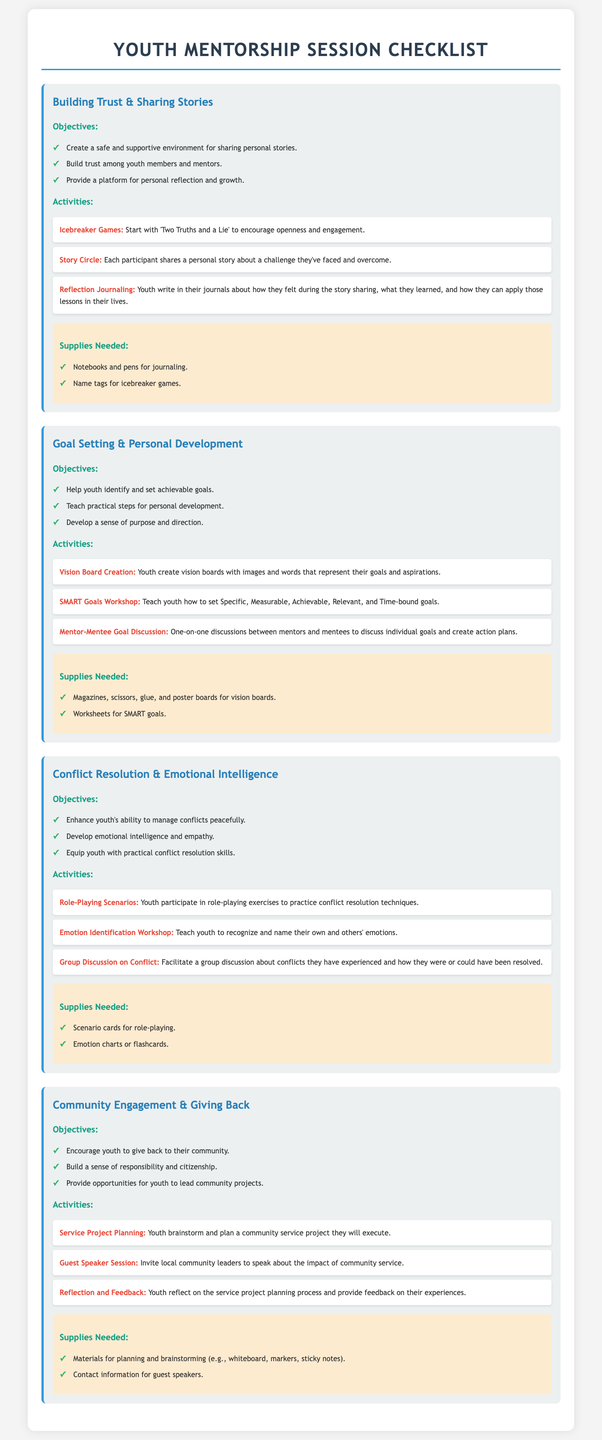What is the first session topic? The first session topic is listed at the beginning under the session headings.
Answer: Building Trust & Sharing Stories How many objectives are listed under the "Goal Setting & Personal Development" session? The document presents a list of objectives under each session, which can be counted for this session.
Answer: Three What activity is planned for emotional intelligence development? The activity for emotional intelligence development is listed under the activities for the session.
Answer: Emotion Identification Workshop What supplies are needed for the "Service Project Planning" activity? The specific supplies required for activities can be found in the supplies section of the session.
Answer: Materials for planning and brainstorming (e.g., whiteboard, markers, sticky notes) Which activity encourages participants to share personal stories? The activity focused on sharing personal stories is named explicitly under the activities for the first session.
Answer: Story Circle How many sessions are outlined in the document? The number of sessions can be determined by counting the session headings presented in the document.
Answer: Four What is one of the objectives of the "Community Engagement & Giving Back" session? Objectives are listed in bullet points for each session, specifying the aims of that session.
Answer: Encourage youth to give back to their community Name one item needed for the journaling activity. Necessary items for journaling can be found in the supplies section of the first session.
Answer: Notebooks and pens 